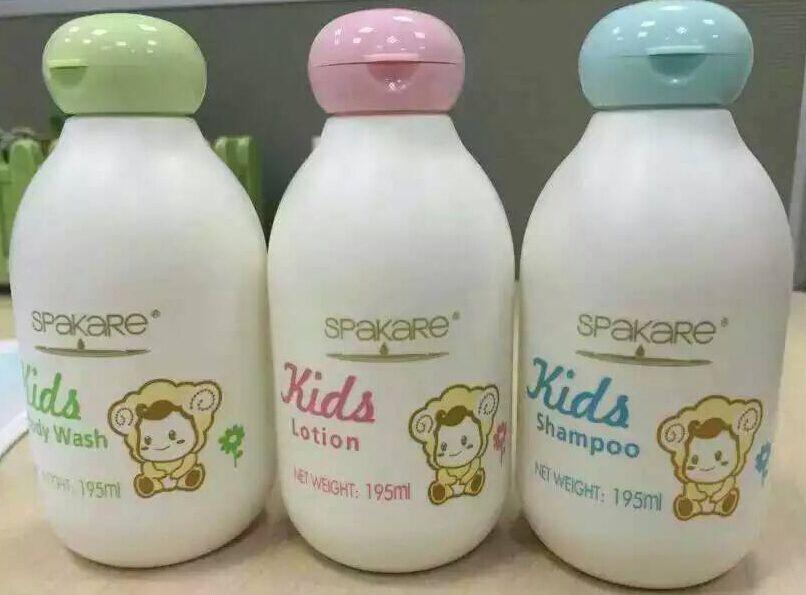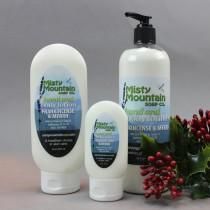The first image is the image on the left, the second image is the image on the right. Evaluate the accuracy of this statement regarding the images: "The left image contains exactly three bottles, all of the same size and shape.". Is it true? Answer yes or no. Yes. The first image is the image on the left, the second image is the image on the right. Considering the images on both sides, is "Some of the bottles in the right image have rounded tops." valid? Answer yes or no. Yes. 